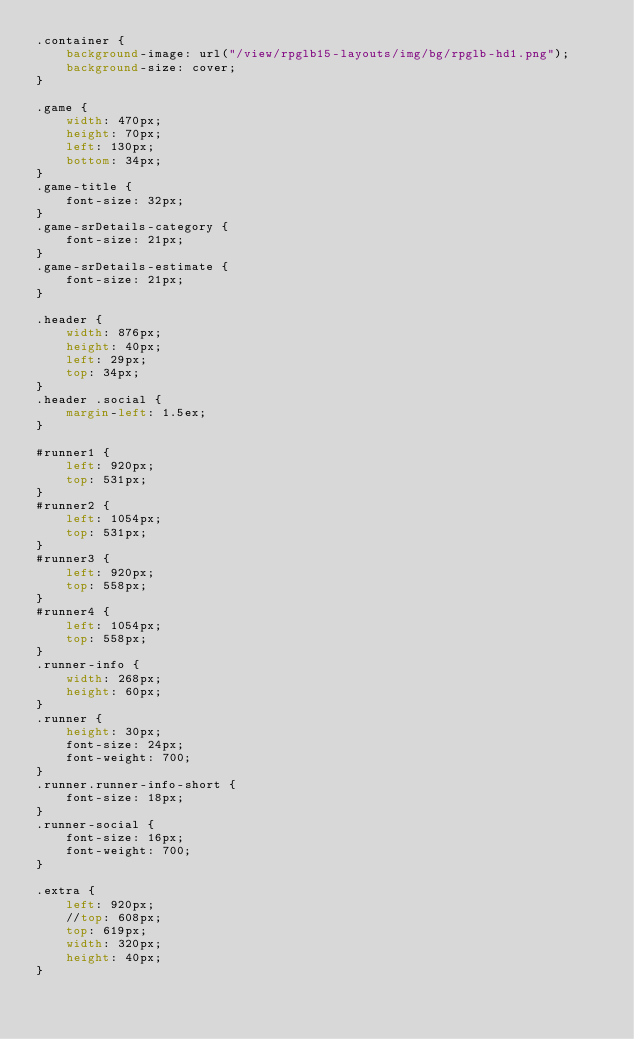<code> <loc_0><loc_0><loc_500><loc_500><_CSS_>.container {
    background-image: url("/view/rpglb15-layouts/img/bg/rpglb-hd1.png");
    background-size: cover;
}

.game {
    width: 470px;
    height: 70px;
    left: 130px;
    bottom: 34px;
}
.game-title {
    font-size: 32px;
}
.game-srDetails-category {
    font-size: 21px;
}
.game-srDetails-estimate {
    font-size: 21px;
}

.header {
    width: 876px;
    height: 40px;
    left: 29px;
    top: 34px;
}
.header .social {
    margin-left: 1.5ex;
}

#runner1 {
    left: 920px;
    top: 531px;
}
#runner2 {
    left: 1054px;
    top: 531px;
}
#runner3 {
    left: 920px;
    top: 558px;
}
#runner4 {
    left: 1054px;
    top: 558px;
}
.runner-info {
    width: 268px;
    height: 60px;
}
.runner {
    height: 30px;
    font-size: 24px;
    font-weight: 700;
}
.runner.runner-info-short {
    font-size: 18px;
}
.runner-social {
    font-size: 16px;
    font-weight: 700;
}

.extra {
    left: 920px;
    //top: 608px;
    top: 619px;
    width: 320px;
    height: 40px;
}</code> 